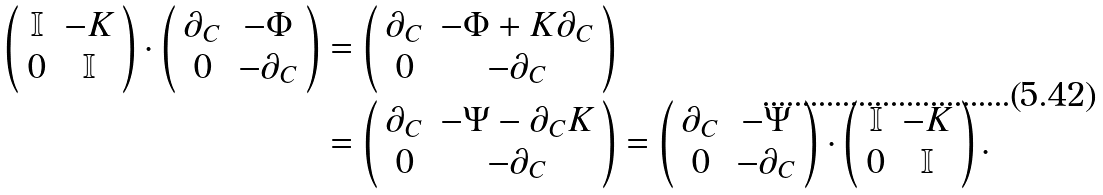Convert formula to latex. <formula><loc_0><loc_0><loc_500><loc_500>\left ( \begin{array} { c c } \mathbb { I } & - K \\ 0 & \mathbb { I } \end{array} \right ) \cdot \left ( \begin{array} { c c } \partial _ { C } & - \Phi \\ 0 & - \partial _ { C } \end{array} \right ) & = \left ( \begin{array} { c c } \partial _ { C } & - \Phi + K \partial _ { C } \\ 0 & - \partial _ { C } \end{array} \right ) \\ & = \left ( \begin{array} { c c } \partial _ { C } & - \Psi - \partial _ { C } K \\ 0 & - \partial _ { C } \end{array} \right ) = \left ( \begin{array} { c c } \partial _ { C } & - \Psi \\ 0 & - \partial _ { C } \end{array} \right ) \cdot \left ( \begin{array} { c c } \mathbb { I } & - K \\ 0 & \mathbb { I } \end{array} \right ) .</formula> 